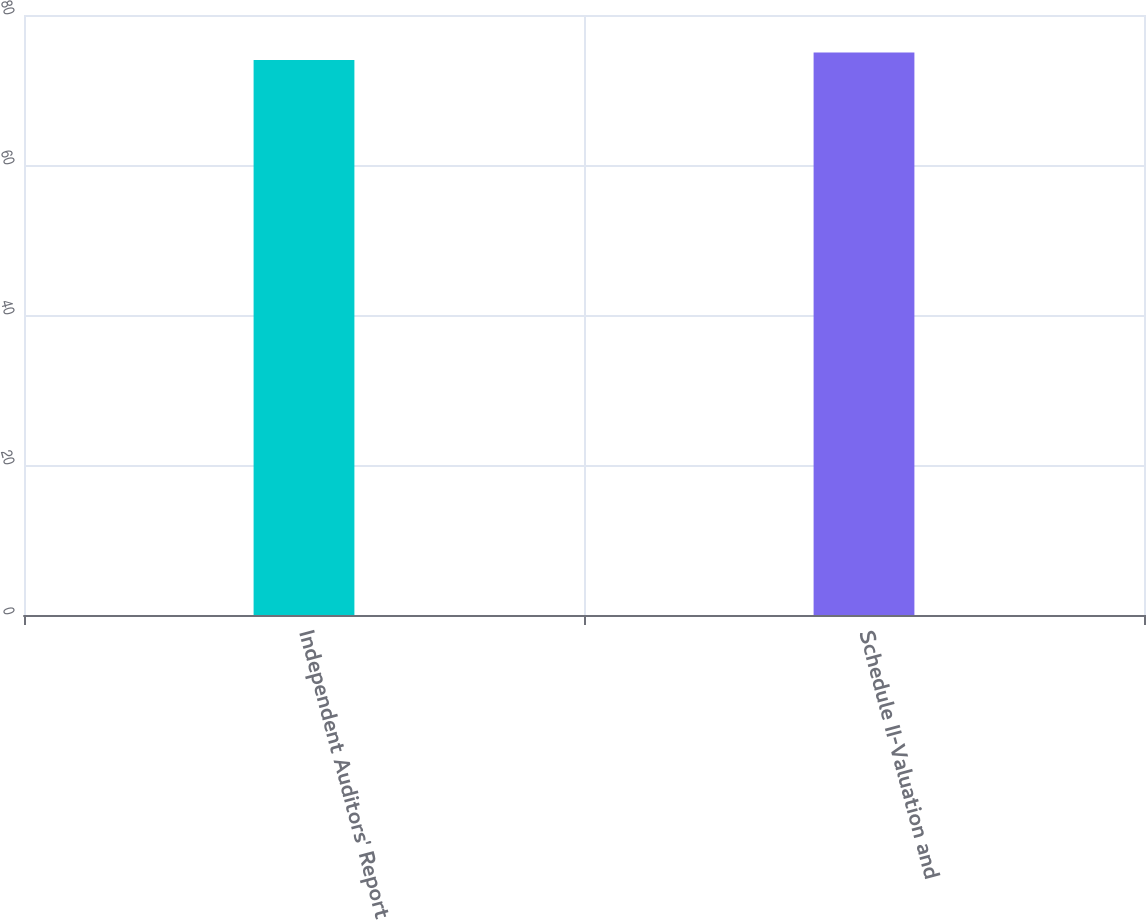Convert chart. <chart><loc_0><loc_0><loc_500><loc_500><bar_chart><fcel>Independent Auditors' Report<fcel>Schedule II-Valuation and<nl><fcel>74<fcel>75<nl></chart> 